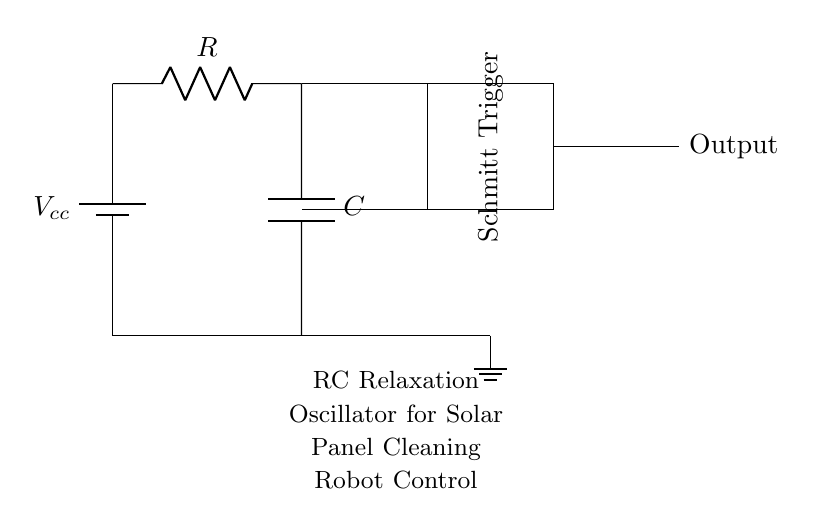What is the type of capacitor used in this circuit? The circuit contains a capacitor labeled "C," which usually indicates a standard capacitor. Its specific type isn't detailed in the diagram, but in such contexts, it might commonly be non-polarized.
Answer: Capacitor What component is used to provide a variable threshold? The Schmitt Trigger provides hysteresis in the circuit, allowing it to switch states based on different voltage thresholds as the capacitor charges or discharges.
Answer: Schmitt Trigger What is the main function of the resistors in this circuit? The resistor "R" controls the charging and discharging time of the capacitor, affecting the frequency of oscillation of the circuit.
Answer: Control timing What happens to the output when the capacitor discharges? When the capacitor discharges, the voltage across it falls below the lower threshold of the Schmitt Trigger, causing the output to toggle to a low state.
Answer: Output toggles low What is the purpose of the feedback path in the circuit? The feedback path connects the output of the Schmitt Trigger back to the charging capacitor, ensuring that the circuit can continuously oscillate.
Answer: Enable oscillation What is the role of the battery in this circuit? The battery supplies the necessary voltage to power the circuit, providing the potential difference needed for the resistor and capacitor to function and for the Schmitt Trigger to operate.
Answer: Power supply 